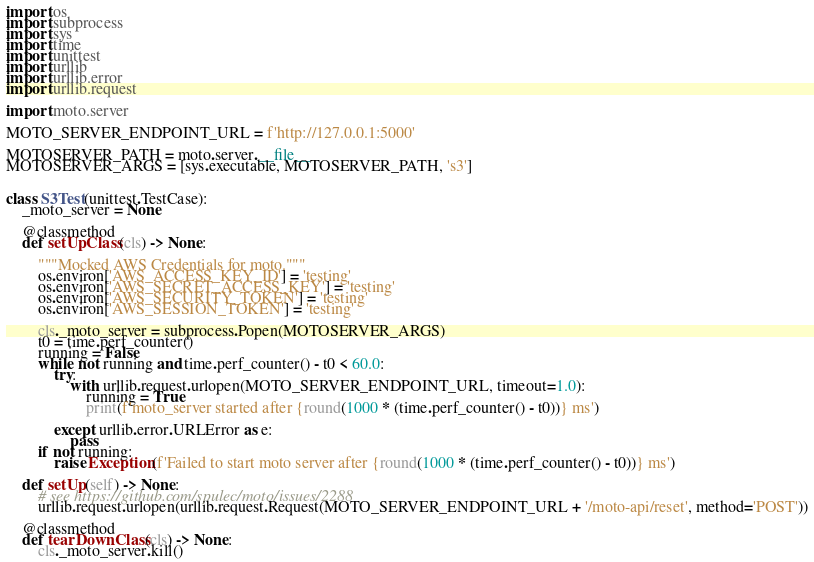Convert code to text. <code><loc_0><loc_0><loc_500><loc_500><_Python_>import os
import subprocess
import sys
import time
import unittest
import urllib
import urllib.error
import urllib.request

import moto.server

MOTO_SERVER_ENDPOINT_URL = f'http://127.0.0.1:5000'

MOTOSERVER_PATH = moto.server.__file__
MOTOSERVER_ARGS = [sys.executable, MOTOSERVER_PATH, 's3']


class S3Test(unittest.TestCase):
    _moto_server = None

    @classmethod
    def setUpClass(cls) -> None:

        """Mocked AWS Credentials for moto."""
        os.environ['AWS_ACCESS_KEY_ID'] = 'testing'
        os.environ['AWS_SECRET_ACCESS_KEY'] = 'testing'
        os.environ['AWS_SECURITY_TOKEN'] = 'testing'
        os.environ['AWS_SESSION_TOKEN'] = 'testing'

        cls._moto_server = subprocess.Popen(MOTOSERVER_ARGS)
        t0 = time.perf_counter()
        running = False
        while not running and time.perf_counter() - t0 < 60.0:
            try:
                with urllib.request.urlopen(MOTO_SERVER_ENDPOINT_URL, timeout=1.0):
                    running = True
                    print(f'moto_server started after {round(1000 * (time.perf_counter() - t0))} ms')

            except urllib.error.URLError as e:
                pass
        if not running:
            raise Exception(f'Failed to start moto server after {round(1000 * (time.perf_counter() - t0))} ms')

    def setUp(self) -> None:
        # see https://github.com/spulec/moto/issues/2288
        urllib.request.urlopen(urllib.request.Request(MOTO_SERVER_ENDPOINT_URL + '/moto-api/reset', method='POST'))

    @classmethod
    def tearDownClass(cls) -> None:
        cls._moto_server.kill()
</code> 